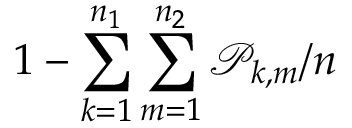Convert formula to latex. <formula><loc_0><loc_0><loc_500><loc_500>1 - \sum _ { k = 1 } ^ { n _ { 1 } } \sum _ { m = 1 } ^ { n _ { 2 } } \mathcal { P } _ { k , m } / n</formula> 